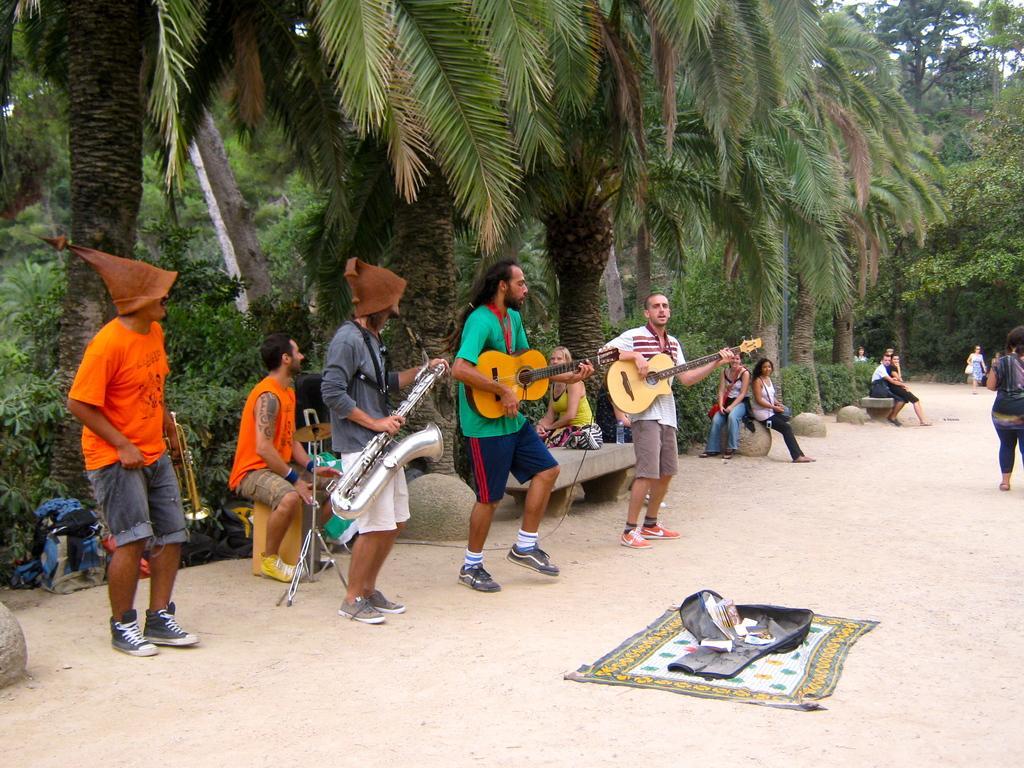Could you give a brief overview of what you see in this image? A group of people are playing musical instruments by the side of a road. 